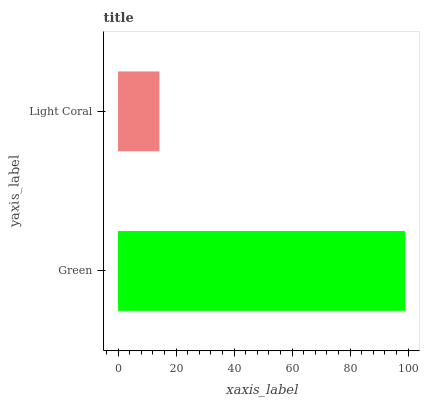Is Light Coral the minimum?
Answer yes or no. Yes. Is Green the maximum?
Answer yes or no. Yes. Is Light Coral the maximum?
Answer yes or no. No. Is Green greater than Light Coral?
Answer yes or no. Yes. Is Light Coral less than Green?
Answer yes or no. Yes. Is Light Coral greater than Green?
Answer yes or no. No. Is Green less than Light Coral?
Answer yes or no. No. Is Green the high median?
Answer yes or no. Yes. Is Light Coral the low median?
Answer yes or no. Yes. Is Light Coral the high median?
Answer yes or no. No. Is Green the low median?
Answer yes or no. No. 